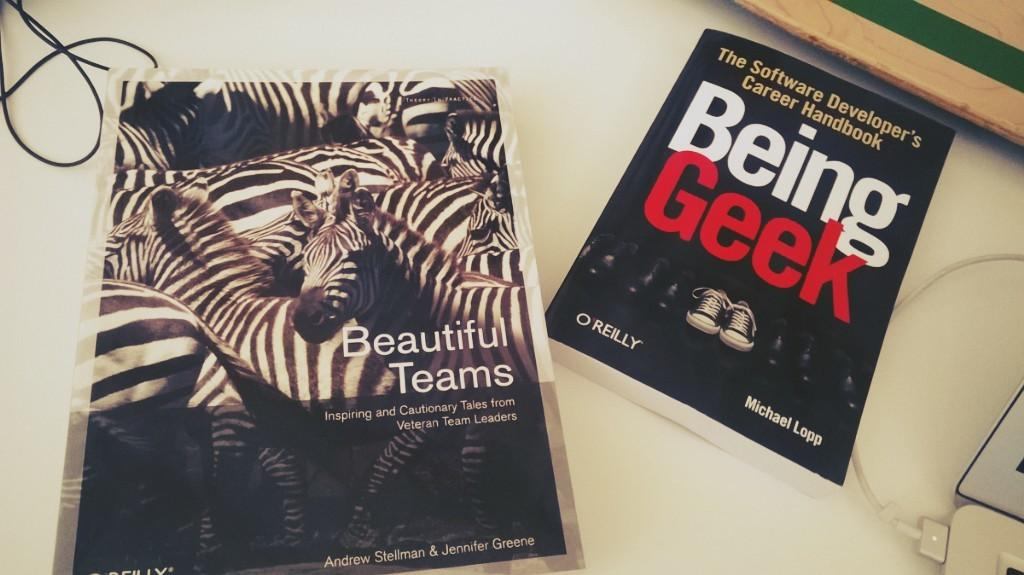Provide a one-sentence caption for the provided image. two books include Beautiful Teams and Being Geek on a table. 